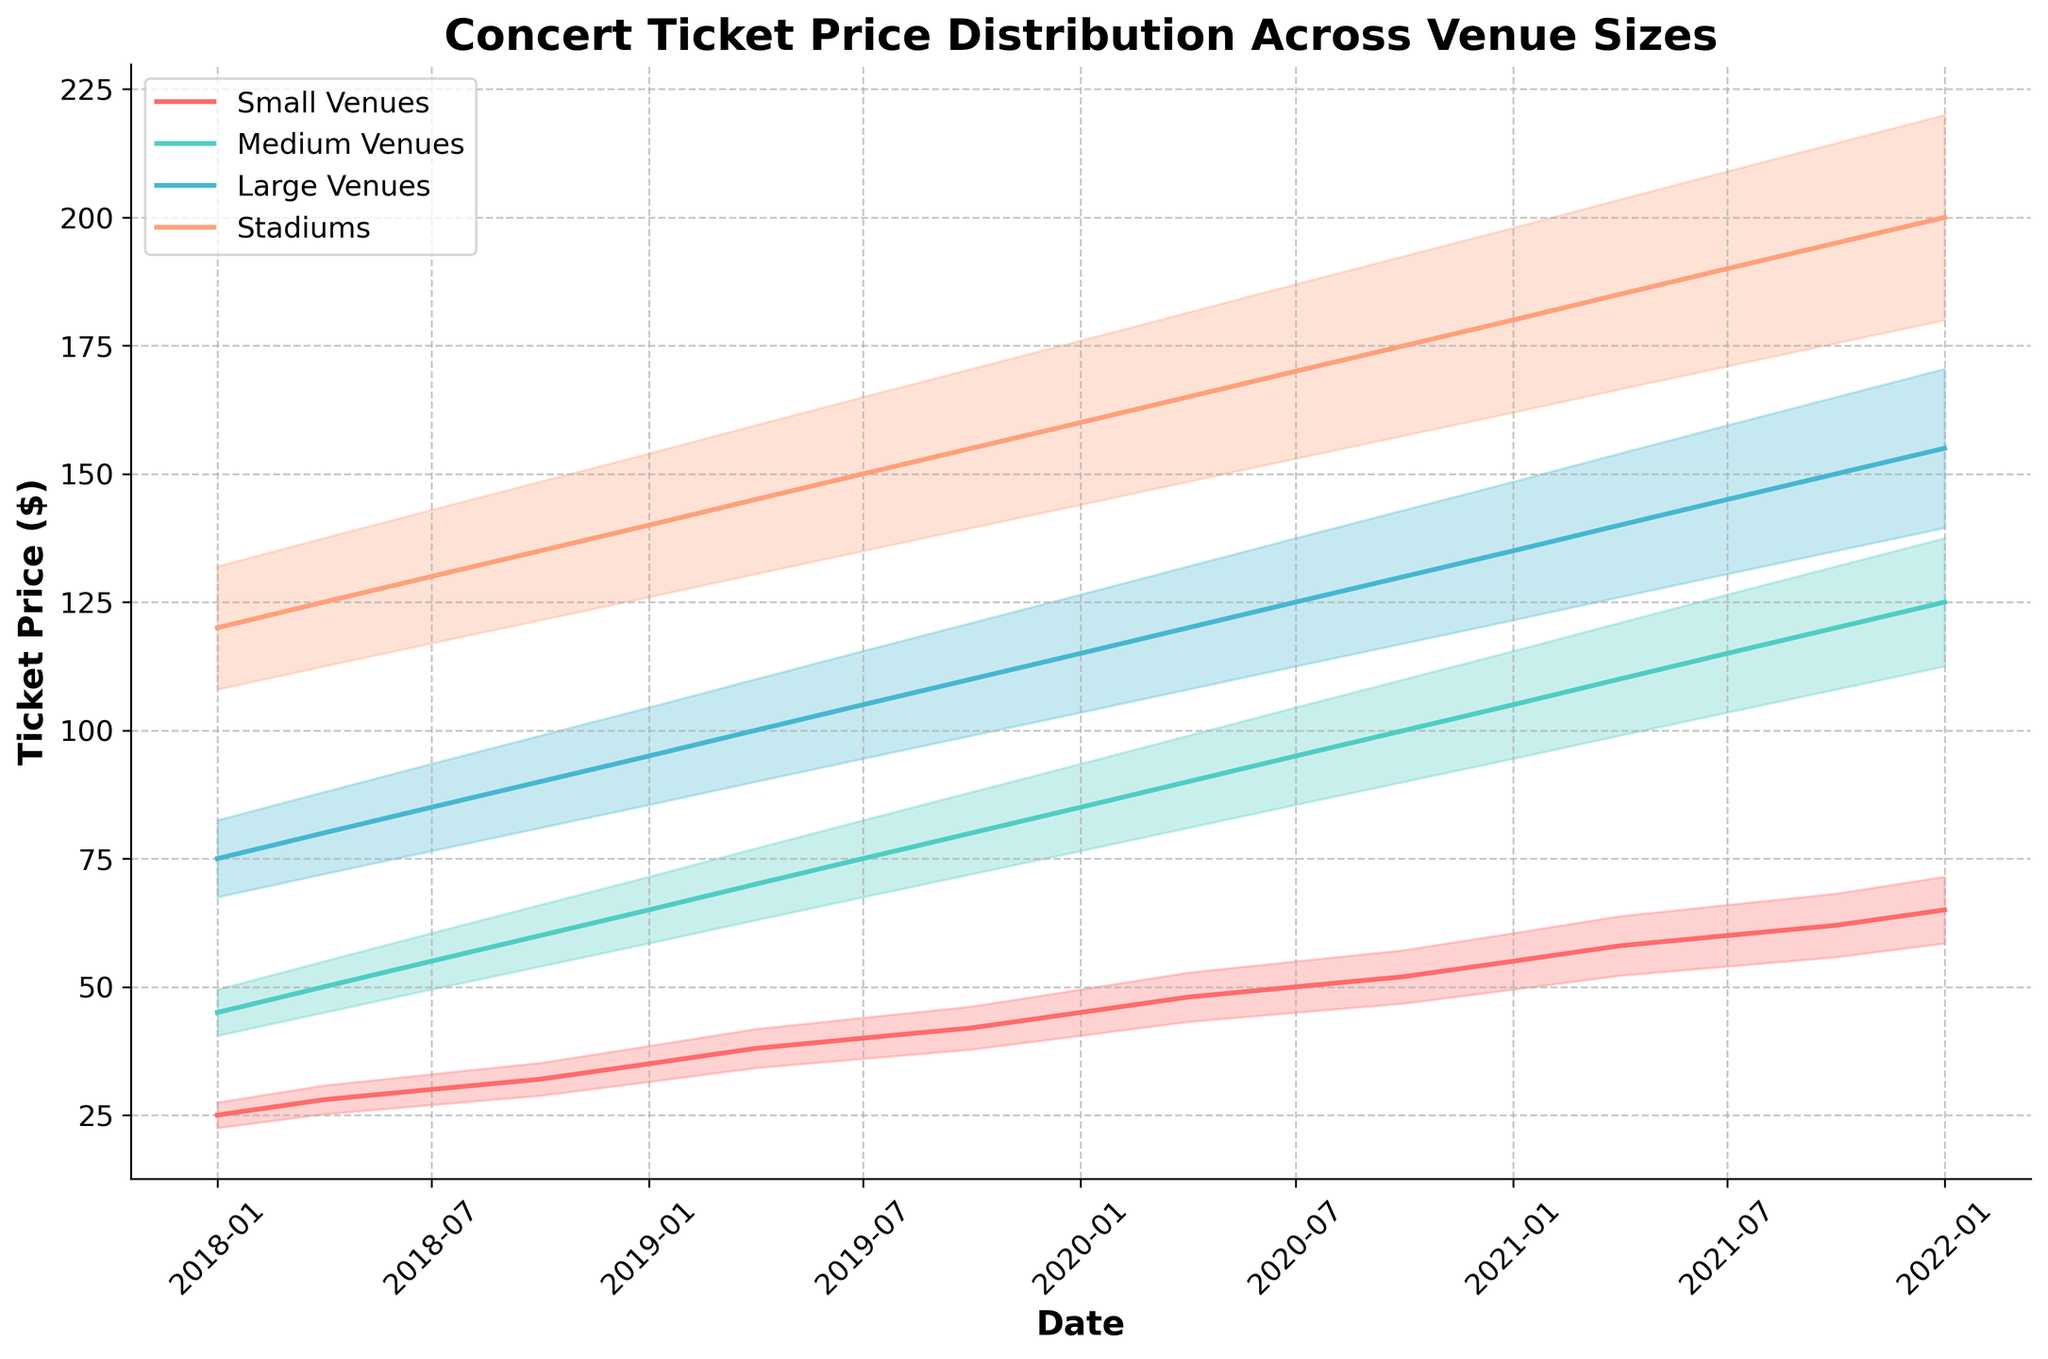What is the title of the chart? The title of the chart is at the top, stating the main information the chart represents.
Answer: Concert Ticket Price Distribution Across Venue Sizes Which line represents the ticket prices for Stadiums? The line representing Stadiums is color-coded. Look for the consistent color used for Stadiums in the legend and follow that line on the chart.
Answer: The orange line What are the ticket prices for Small Venues in January 2021? Locate January 2021 on the x-axis, then follow the corresponding vertical line upwards until you reach the Small Venues line. Read the y-axis value at this intersection.
Answer: $55 By how much did the ticket price for Medium Venues increase from January 2018 to January 2022? Identify the ticket prices for Medium Venues in January 2018 and January 2022 by following the Medium Venues line and reading the values from the y-axis. Subtract the earlier price from the later one.
Answer: $75 Which type of venue had the steepest increase in ticket prices from 2018 to 2022? Compare the slopes of the lines for each venue type from 2018 to 2022. The steepest slope indicates the greatest price increase.
Answer: Stadiums What was the ticket price range for Large Venues in April 2020? Locate April 2020 on the x-axis and then identify the value for Large Venues. Calculate the range as 10% below and 10% above this value.
Answer: $112.50 to $137.50 Which venue type had the smallest price increase in July 2018? Check the changes in ticket prices for all venue types between April 2018 and July 2018 by comparing the y-axis values. Determine which has the smallest difference.
Answer: Small Venues How much higher were Stadium ticket prices compared to Small Venues in October 2021? Find the ticket prices for both venue types in October 2021 by following their respective lines to the y-axis and subtract the Small Venues price from the Stadium price.
Answer: $133 What is the trend observed in the ticket prices for all venue types from 2018 to 2022? Observe the direction and pattern of all four lines across the entire time span on the x-axis to identify whether they are increasing, decreasing, or remaining flat.
Answer: Increasing Are ticket prices more volatile for Small Venues or Large Venues? Examine the filled areas around each line for Small Venues and Large Venues. Larger filled areas indicate higher volatility.
Answer: Large Venues 